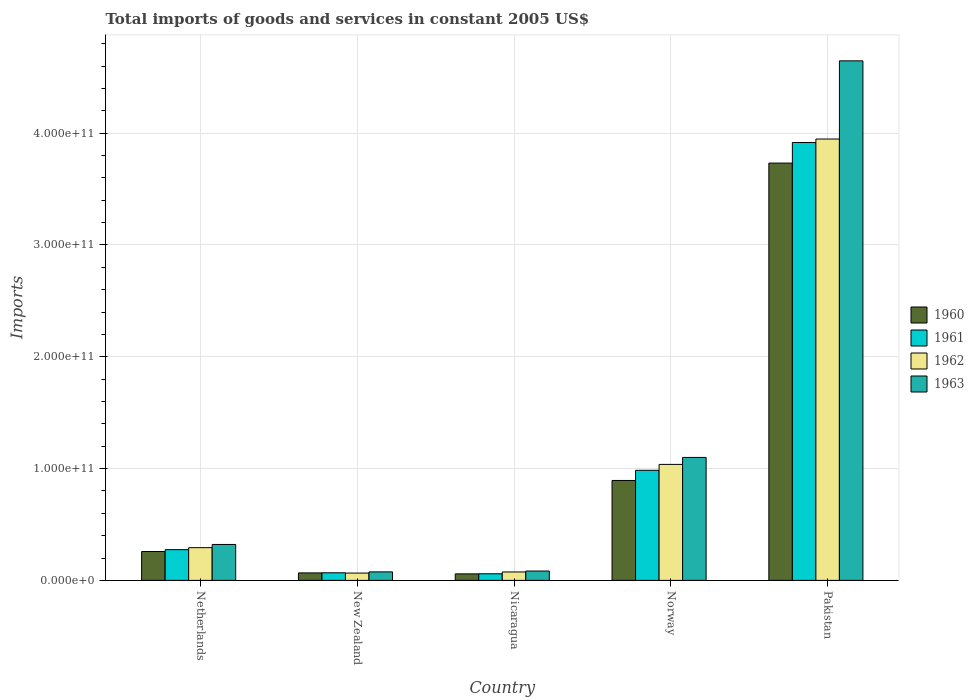How many different coloured bars are there?
Your answer should be compact. 4. How many bars are there on the 2nd tick from the right?
Your answer should be very brief. 4. What is the total imports of goods and services in 1963 in New Zealand?
Your answer should be compact. 7.62e+09. Across all countries, what is the maximum total imports of goods and services in 1962?
Provide a short and direct response. 3.95e+11. Across all countries, what is the minimum total imports of goods and services in 1962?
Make the answer very short. 6.55e+09. In which country was the total imports of goods and services in 1963 minimum?
Keep it short and to the point. New Zealand. What is the total total imports of goods and services in 1960 in the graph?
Give a very brief answer. 5.01e+11. What is the difference between the total imports of goods and services in 1960 in Norway and that in Pakistan?
Provide a succinct answer. -2.84e+11. What is the difference between the total imports of goods and services in 1960 in Netherlands and the total imports of goods and services in 1962 in Norway?
Make the answer very short. -7.79e+1. What is the average total imports of goods and services in 1960 per country?
Your answer should be compact. 1.00e+11. What is the difference between the total imports of goods and services of/in 1960 and total imports of goods and services of/in 1962 in Pakistan?
Offer a very short reply. -2.15e+1. In how many countries, is the total imports of goods and services in 1960 greater than 420000000000 US$?
Offer a terse response. 0. What is the ratio of the total imports of goods and services in 1962 in Nicaragua to that in Pakistan?
Ensure brevity in your answer.  0.02. What is the difference between the highest and the second highest total imports of goods and services in 1960?
Provide a succinct answer. 2.84e+11. What is the difference between the highest and the lowest total imports of goods and services in 1962?
Your answer should be compact. 3.88e+11. Is the sum of the total imports of goods and services in 1960 in Netherlands and New Zealand greater than the maximum total imports of goods and services in 1961 across all countries?
Make the answer very short. No. What does the 3rd bar from the right in Pakistan represents?
Offer a very short reply. 1961. What is the difference between two consecutive major ticks on the Y-axis?
Keep it short and to the point. 1.00e+11. Are the values on the major ticks of Y-axis written in scientific E-notation?
Your response must be concise. Yes. Does the graph contain any zero values?
Give a very brief answer. No. Does the graph contain grids?
Your answer should be very brief. Yes. Where does the legend appear in the graph?
Your response must be concise. Center right. How are the legend labels stacked?
Offer a terse response. Vertical. What is the title of the graph?
Offer a very short reply. Total imports of goods and services in constant 2005 US$. Does "2011" appear as one of the legend labels in the graph?
Keep it short and to the point. No. What is the label or title of the X-axis?
Provide a short and direct response. Country. What is the label or title of the Y-axis?
Ensure brevity in your answer.  Imports. What is the Imports of 1960 in Netherlands?
Give a very brief answer. 2.58e+1. What is the Imports in 1961 in Netherlands?
Your answer should be very brief. 2.75e+1. What is the Imports of 1962 in Netherlands?
Your response must be concise. 2.93e+1. What is the Imports in 1963 in Netherlands?
Provide a short and direct response. 3.21e+1. What is the Imports of 1960 in New Zealand?
Offer a very short reply. 6.71e+09. What is the Imports in 1961 in New Zealand?
Make the answer very short. 6.81e+09. What is the Imports in 1962 in New Zealand?
Offer a terse response. 6.55e+09. What is the Imports of 1963 in New Zealand?
Keep it short and to the point. 7.62e+09. What is the Imports of 1960 in Nicaragua?
Your answer should be very brief. 5.84e+09. What is the Imports in 1961 in Nicaragua?
Ensure brevity in your answer.  5.92e+09. What is the Imports of 1962 in Nicaragua?
Offer a terse response. 7.54e+09. What is the Imports in 1963 in Nicaragua?
Give a very brief answer. 8.36e+09. What is the Imports of 1960 in Norway?
Provide a succinct answer. 8.94e+1. What is the Imports of 1961 in Norway?
Provide a short and direct response. 9.85e+1. What is the Imports in 1962 in Norway?
Offer a terse response. 1.04e+11. What is the Imports of 1963 in Norway?
Provide a succinct answer. 1.10e+11. What is the Imports in 1960 in Pakistan?
Ensure brevity in your answer.  3.73e+11. What is the Imports of 1961 in Pakistan?
Your response must be concise. 3.92e+11. What is the Imports in 1962 in Pakistan?
Make the answer very short. 3.95e+11. What is the Imports in 1963 in Pakistan?
Your answer should be compact. 4.65e+11. Across all countries, what is the maximum Imports in 1960?
Ensure brevity in your answer.  3.73e+11. Across all countries, what is the maximum Imports in 1961?
Keep it short and to the point. 3.92e+11. Across all countries, what is the maximum Imports of 1962?
Your answer should be very brief. 3.95e+11. Across all countries, what is the maximum Imports in 1963?
Your response must be concise. 4.65e+11. Across all countries, what is the minimum Imports of 1960?
Keep it short and to the point. 5.84e+09. Across all countries, what is the minimum Imports of 1961?
Make the answer very short. 5.92e+09. Across all countries, what is the minimum Imports in 1962?
Offer a terse response. 6.55e+09. Across all countries, what is the minimum Imports of 1963?
Provide a succinct answer. 7.62e+09. What is the total Imports of 1960 in the graph?
Make the answer very short. 5.01e+11. What is the total Imports in 1961 in the graph?
Keep it short and to the point. 5.30e+11. What is the total Imports of 1962 in the graph?
Your answer should be compact. 5.42e+11. What is the total Imports in 1963 in the graph?
Provide a succinct answer. 6.23e+11. What is the difference between the Imports of 1960 in Netherlands and that in New Zealand?
Your answer should be compact. 1.91e+1. What is the difference between the Imports of 1961 in Netherlands and that in New Zealand?
Offer a very short reply. 2.07e+1. What is the difference between the Imports in 1962 in Netherlands and that in New Zealand?
Your answer should be compact. 2.27e+1. What is the difference between the Imports of 1963 in Netherlands and that in New Zealand?
Provide a short and direct response. 2.45e+1. What is the difference between the Imports in 1960 in Netherlands and that in Nicaragua?
Keep it short and to the point. 2.00e+1. What is the difference between the Imports of 1961 in Netherlands and that in Nicaragua?
Provide a succinct answer. 2.16e+1. What is the difference between the Imports of 1962 in Netherlands and that in Nicaragua?
Your answer should be very brief. 2.17e+1. What is the difference between the Imports in 1963 in Netherlands and that in Nicaragua?
Offer a very short reply. 2.38e+1. What is the difference between the Imports of 1960 in Netherlands and that in Norway?
Your response must be concise. -6.35e+1. What is the difference between the Imports in 1961 in Netherlands and that in Norway?
Give a very brief answer. -7.10e+1. What is the difference between the Imports in 1962 in Netherlands and that in Norway?
Provide a succinct answer. -7.45e+1. What is the difference between the Imports of 1963 in Netherlands and that in Norway?
Provide a succinct answer. -7.78e+1. What is the difference between the Imports of 1960 in Netherlands and that in Pakistan?
Offer a very short reply. -3.47e+11. What is the difference between the Imports of 1961 in Netherlands and that in Pakistan?
Your answer should be very brief. -3.64e+11. What is the difference between the Imports in 1962 in Netherlands and that in Pakistan?
Your response must be concise. -3.66e+11. What is the difference between the Imports of 1963 in Netherlands and that in Pakistan?
Provide a short and direct response. -4.33e+11. What is the difference between the Imports of 1960 in New Zealand and that in Nicaragua?
Offer a terse response. 8.66e+08. What is the difference between the Imports in 1961 in New Zealand and that in Nicaragua?
Provide a short and direct response. 8.81e+08. What is the difference between the Imports of 1962 in New Zealand and that in Nicaragua?
Offer a terse response. -9.91e+08. What is the difference between the Imports of 1963 in New Zealand and that in Nicaragua?
Make the answer very short. -7.46e+08. What is the difference between the Imports of 1960 in New Zealand and that in Norway?
Ensure brevity in your answer.  -8.27e+1. What is the difference between the Imports of 1961 in New Zealand and that in Norway?
Make the answer very short. -9.17e+1. What is the difference between the Imports in 1962 in New Zealand and that in Norway?
Give a very brief answer. -9.72e+1. What is the difference between the Imports of 1963 in New Zealand and that in Norway?
Make the answer very short. -1.02e+11. What is the difference between the Imports of 1960 in New Zealand and that in Pakistan?
Your answer should be very brief. -3.67e+11. What is the difference between the Imports of 1961 in New Zealand and that in Pakistan?
Provide a short and direct response. -3.85e+11. What is the difference between the Imports in 1962 in New Zealand and that in Pakistan?
Keep it short and to the point. -3.88e+11. What is the difference between the Imports of 1963 in New Zealand and that in Pakistan?
Make the answer very short. -4.57e+11. What is the difference between the Imports in 1960 in Nicaragua and that in Norway?
Ensure brevity in your answer.  -8.35e+1. What is the difference between the Imports in 1961 in Nicaragua and that in Norway?
Offer a terse response. -9.25e+1. What is the difference between the Imports in 1962 in Nicaragua and that in Norway?
Your answer should be compact. -9.62e+1. What is the difference between the Imports in 1963 in Nicaragua and that in Norway?
Ensure brevity in your answer.  -1.02e+11. What is the difference between the Imports in 1960 in Nicaragua and that in Pakistan?
Give a very brief answer. -3.67e+11. What is the difference between the Imports of 1961 in Nicaragua and that in Pakistan?
Keep it short and to the point. -3.86e+11. What is the difference between the Imports in 1962 in Nicaragua and that in Pakistan?
Make the answer very short. -3.87e+11. What is the difference between the Imports in 1963 in Nicaragua and that in Pakistan?
Offer a very short reply. -4.56e+11. What is the difference between the Imports in 1960 in Norway and that in Pakistan?
Provide a succinct answer. -2.84e+11. What is the difference between the Imports of 1961 in Norway and that in Pakistan?
Offer a terse response. -2.93e+11. What is the difference between the Imports of 1962 in Norway and that in Pakistan?
Ensure brevity in your answer.  -2.91e+11. What is the difference between the Imports of 1963 in Norway and that in Pakistan?
Your answer should be compact. -3.55e+11. What is the difference between the Imports of 1960 in Netherlands and the Imports of 1961 in New Zealand?
Offer a very short reply. 1.90e+1. What is the difference between the Imports in 1960 in Netherlands and the Imports in 1962 in New Zealand?
Offer a terse response. 1.93e+1. What is the difference between the Imports in 1960 in Netherlands and the Imports in 1963 in New Zealand?
Give a very brief answer. 1.82e+1. What is the difference between the Imports in 1961 in Netherlands and the Imports in 1962 in New Zealand?
Ensure brevity in your answer.  2.10e+1. What is the difference between the Imports of 1961 in Netherlands and the Imports of 1963 in New Zealand?
Give a very brief answer. 1.99e+1. What is the difference between the Imports in 1962 in Netherlands and the Imports in 1963 in New Zealand?
Offer a terse response. 2.17e+1. What is the difference between the Imports of 1960 in Netherlands and the Imports of 1961 in Nicaragua?
Keep it short and to the point. 1.99e+1. What is the difference between the Imports of 1960 in Netherlands and the Imports of 1962 in Nicaragua?
Your answer should be very brief. 1.83e+1. What is the difference between the Imports in 1960 in Netherlands and the Imports in 1963 in Nicaragua?
Your response must be concise. 1.75e+1. What is the difference between the Imports of 1961 in Netherlands and the Imports of 1962 in Nicaragua?
Keep it short and to the point. 2.00e+1. What is the difference between the Imports in 1961 in Netherlands and the Imports in 1963 in Nicaragua?
Your answer should be compact. 1.91e+1. What is the difference between the Imports in 1962 in Netherlands and the Imports in 1963 in Nicaragua?
Offer a terse response. 2.09e+1. What is the difference between the Imports of 1960 in Netherlands and the Imports of 1961 in Norway?
Provide a short and direct response. -7.26e+1. What is the difference between the Imports of 1960 in Netherlands and the Imports of 1962 in Norway?
Your response must be concise. -7.79e+1. What is the difference between the Imports in 1960 in Netherlands and the Imports in 1963 in Norway?
Offer a terse response. -8.41e+1. What is the difference between the Imports in 1961 in Netherlands and the Imports in 1962 in Norway?
Make the answer very short. -7.62e+1. What is the difference between the Imports of 1961 in Netherlands and the Imports of 1963 in Norway?
Provide a succinct answer. -8.25e+1. What is the difference between the Imports of 1962 in Netherlands and the Imports of 1963 in Norway?
Provide a succinct answer. -8.07e+1. What is the difference between the Imports in 1960 in Netherlands and the Imports in 1961 in Pakistan?
Offer a very short reply. -3.66e+11. What is the difference between the Imports in 1960 in Netherlands and the Imports in 1962 in Pakistan?
Ensure brevity in your answer.  -3.69e+11. What is the difference between the Imports in 1960 in Netherlands and the Imports in 1963 in Pakistan?
Provide a short and direct response. -4.39e+11. What is the difference between the Imports of 1961 in Netherlands and the Imports of 1962 in Pakistan?
Your answer should be compact. -3.67e+11. What is the difference between the Imports of 1961 in Netherlands and the Imports of 1963 in Pakistan?
Provide a succinct answer. -4.37e+11. What is the difference between the Imports in 1962 in Netherlands and the Imports in 1963 in Pakistan?
Your answer should be compact. -4.35e+11. What is the difference between the Imports in 1960 in New Zealand and the Imports in 1961 in Nicaragua?
Ensure brevity in your answer.  7.83e+08. What is the difference between the Imports in 1960 in New Zealand and the Imports in 1962 in Nicaragua?
Provide a short and direct response. -8.30e+08. What is the difference between the Imports of 1960 in New Zealand and the Imports of 1963 in Nicaragua?
Ensure brevity in your answer.  -1.66e+09. What is the difference between the Imports in 1961 in New Zealand and the Imports in 1962 in Nicaragua?
Your answer should be very brief. -7.32e+08. What is the difference between the Imports of 1961 in New Zealand and the Imports of 1963 in Nicaragua?
Provide a short and direct response. -1.56e+09. What is the difference between the Imports in 1962 in New Zealand and the Imports in 1963 in Nicaragua?
Your response must be concise. -1.82e+09. What is the difference between the Imports in 1960 in New Zealand and the Imports in 1961 in Norway?
Provide a succinct answer. -9.18e+1. What is the difference between the Imports of 1960 in New Zealand and the Imports of 1962 in Norway?
Your answer should be very brief. -9.70e+1. What is the difference between the Imports of 1960 in New Zealand and the Imports of 1963 in Norway?
Your response must be concise. -1.03e+11. What is the difference between the Imports of 1961 in New Zealand and the Imports of 1962 in Norway?
Your answer should be compact. -9.69e+1. What is the difference between the Imports of 1961 in New Zealand and the Imports of 1963 in Norway?
Provide a succinct answer. -1.03e+11. What is the difference between the Imports of 1962 in New Zealand and the Imports of 1963 in Norway?
Offer a terse response. -1.03e+11. What is the difference between the Imports of 1960 in New Zealand and the Imports of 1961 in Pakistan?
Provide a succinct answer. -3.85e+11. What is the difference between the Imports in 1960 in New Zealand and the Imports in 1962 in Pakistan?
Offer a terse response. -3.88e+11. What is the difference between the Imports in 1960 in New Zealand and the Imports in 1963 in Pakistan?
Provide a short and direct response. -4.58e+11. What is the difference between the Imports in 1961 in New Zealand and the Imports in 1962 in Pakistan?
Make the answer very short. -3.88e+11. What is the difference between the Imports in 1961 in New Zealand and the Imports in 1963 in Pakistan?
Offer a very short reply. -4.58e+11. What is the difference between the Imports of 1962 in New Zealand and the Imports of 1963 in Pakistan?
Provide a succinct answer. -4.58e+11. What is the difference between the Imports in 1960 in Nicaragua and the Imports in 1961 in Norway?
Your answer should be compact. -9.26e+1. What is the difference between the Imports in 1960 in Nicaragua and the Imports in 1962 in Norway?
Your response must be concise. -9.79e+1. What is the difference between the Imports of 1960 in Nicaragua and the Imports of 1963 in Norway?
Give a very brief answer. -1.04e+11. What is the difference between the Imports in 1961 in Nicaragua and the Imports in 1962 in Norway?
Your answer should be very brief. -9.78e+1. What is the difference between the Imports in 1961 in Nicaragua and the Imports in 1963 in Norway?
Provide a short and direct response. -1.04e+11. What is the difference between the Imports in 1962 in Nicaragua and the Imports in 1963 in Norway?
Offer a terse response. -1.02e+11. What is the difference between the Imports in 1960 in Nicaragua and the Imports in 1961 in Pakistan?
Provide a short and direct response. -3.86e+11. What is the difference between the Imports of 1960 in Nicaragua and the Imports of 1962 in Pakistan?
Ensure brevity in your answer.  -3.89e+11. What is the difference between the Imports of 1960 in Nicaragua and the Imports of 1963 in Pakistan?
Your answer should be compact. -4.59e+11. What is the difference between the Imports of 1961 in Nicaragua and the Imports of 1962 in Pakistan?
Offer a terse response. -3.89e+11. What is the difference between the Imports of 1961 in Nicaragua and the Imports of 1963 in Pakistan?
Provide a short and direct response. -4.59e+11. What is the difference between the Imports of 1962 in Nicaragua and the Imports of 1963 in Pakistan?
Offer a very short reply. -4.57e+11. What is the difference between the Imports of 1960 in Norway and the Imports of 1961 in Pakistan?
Offer a very short reply. -3.02e+11. What is the difference between the Imports in 1960 in Norway and the Imports in 1962 in Pakistan?
Provide a succinct answer. -3.05e+11. What is the difference between the Imports in 1960 in Norway and the Imports in 1963 in Pakistan?
Your answer should be very brief. -3.75e+11. What is the difference between the Imports in 1961 in Norway and the Imports in 1962 in Pakistan?
Make the answer very short. -2.96e+11. What is the difference between the Imports of 1961 in Norway and the Imports of 1963 in Pakistan?
Offer a very short reply. -3.66e+11. What is the difference between the Imports in 1962 in Norway and the Imports in 1963 in Pakistan?
Provide a short and direct response. -3.61e+11. What is the average Imports of 1960 per country?
Provide a succinct answer. 1.00e+11. What is the average Imports of 1961 per country?
Ensure brevity in your answer.  1.06e+11. What is the average Imports in 1962 per country?
Your answer should be compact. 1.08e+11. What is the average Imports of 1963 per country?
Your response must be concise. 1.25e+11. What is the difference between the Imports of 1960 and Imports of 1961 in Netherlands?
Keep it short and to the point. -1.65e+09. What is the difference between the Imports in 1960 and Imports in 1962 in Netherlands?
Offer a very short reply. -3.43e+09. What is the difference between the Imports of 1960 and Imports of 1963 in Netherlands?
Ensure brevity in your answer.  -6.30e+09. What is the difference between the Imports in 1961 and Imports in 1962 in Netherlands?
Your answer should be compact. -1.77e+09. What is the difference between the Imports in 1961 and Imports in 1963 in Netherlands?
Ensure brevity in your answer.  -4.65e+09. What is the difference between the Imports of 1962 and Imports of 1963 in Netherlands?
Make the answer very short. -2.87e+09. What is the difference between the Imports of 1960 and Imports of 1961 in New Zealand?
Make the answer very short. -9.87e+07. What is the difference between the Imports of 1960 and Imports of 1962 in New Zealand?
Ensure brevity in your answer.  1.61e+08. What is the difference between the Imports in 1960 and Imports in 1963 in New Zealand?
Ensure brevity in your answer.  -9.09e+08. What is the difference between the Imports in 1961 and Imports in 1962 in New Zealand?
Keep it short and to the point. 2.60e+08. What is the difference between the Imports in 1961 and Imports in 1963 in New Zealand?
Your answer should be very brief. -8.10e+08. What is the difference between the Imports in 1962 and Imports in 1963 in New Zealand?
Provide a short and direct response. -1.07e+09. What is the difference between the Imports in 1960 and Imports in 1961 in Nicaragua?
Ensure brevity in your answer.  -8.34e+07. What is the difference between the Imports in 1960 and Imports in 1962 in Nicaragua?
Provide a short and direct response. -1.70e+09. What is the difference between the Imports in 1960 and Imports in 1963 in Nicaragua?
Offer a terse response. -2.52e+09. What is the difference between the Imports in 1961 and Imports in 1962 in Nicaragua?
Give a very brief answer. -1.61e+09. What is the difference between the Imports in 1961 and Imports in 1963 in Nicaragua?
Provide a succinct answer. -2.44e+09. What is the difference between the Imports of 1962 and Imports of 1963 in Nicaragua?
Your answer should be very brief. -8.25e+08. What is the difference between the Imports in 1960 and Imports in 1961 in Norway?
Offer a terse response. -9.07e+09. What is the difference between the Imports in 1960 and Imports in 1962 in Norway?
Keep it short and to the point. -1.44e+1. What is the difference between the Imports of 1960 and Imports of 1963 in Norway?
Keep it short and to the point. -2.06e+1. What is the difference between the Imports of 1961 and Imports of 1962 in Norway?
Keep it short and to the point. -5.28e+09. What is the difference between the Imports in 1961 and Imports in 1963 in Norway?
Make the answer very short. -1.15e+1. What is the difference between the Imports of 1962 and Imports of 1963 in Norway?
Offer a very short reply. -6.24e+09. What is the difference between the Imports of 1960 and Imports of 1961 in Pakistan?
Provide a short and direct response. -1.84e+1. What is the difference between the Imports in 1960 and Imports in 1962 in Pakistan?
Keep it short and to the point. -2.15e+1. What is the difference between the Imports of 1960 and Imports of 1963 in Pakistan?
Ensure brevity in your answer.  -9.14e+1. What is the difference between the Imports in 1961 and Imports in 1962 in Pakistan?
Keep it short and to the point. -3.12e+09. What is the difference between the Imports in 1961 and Imports in 1963 in Pakistan?
Ensure brevity in your answer.  -7.30e+1. What is the difference between the Imports in 1962 and Imports in 1963 in Pakistan?
Your answer should be very brief. -6.99e+1. What is the ratio of the Imports in 1960 in Netherlands to that in New Zealand?
Keep it short and to the point. 3.85. What is the ratio of the Imports in 1961 in Netherlands to that in New Zealand?
Ensure brevity in your answer.  4.04. What is the ratio of the Imports in 1962 in Netherlands to that in New Zealand?
Offer a terse response. 4.47. What is the ratio of the Imports in 1963 in Netherlands to that in New Zealand?
Make the answer very short. 4.22. What is the ratio of the Imports of 1960 in Netherlands to that in Nicaragua?
Ensure brevity in your answer.  4.42. What is the ratio of the Imports of 1961 in Netherlands to that in Nicaragua?
Offer a terse response. 4.64. What is the ratio of the Imports of 1962 in Netherlands to that in Nicaragua?
Offer a terse response. 3.88. What is the ratio of the Imports of 1963 in Netherlands to that in Nicaragua?
Give a very brief answer. 3.84. What is the ratio of the Imports in 1960 in Netherlands to that in Norway?
Your response must be concise. 0.29. What is the ratio of the Imports in 1961 in Netherlands to that in Norway?
Provide a short and direct response. 0.28. What is the ratio of the Imports in 1962 in Netherlands to that in Norway?
Make the answer very short. 0.28. What is the ratio of the Imports of 1963 in Netherlands to that in Norway?
Provide a short and direct response. 0.29. What is the ratio of the Imports in 1960 in Netherlands to that in Pakistan?
Provide a short and direct response. 0.07. What is the ratio of the Imports in 1961 in Netherlands to that in Pakistan?
Your answer should be compact. 0.07. What is the ratio of the Imports of 1962 in Netherlands to that in Pakistan?
Ensure brevity in your answer.  0.07. What is the ratio of the Imports of 1963 in Netherlands to that in Pakistan?
Give a very brief answer. 0.07. What is the ratio of the Imports in 1960 in New Zealand to that in Nicaragua?
Your answer should be compact. 1.15. What is the ratio of the Imports in 1961 in New Zealand to that in Nicaragua?
Provide a short and direct response. 1.15. What is the ratio of the Imports of 1962 in New Zealand to that in Nicaragua?
Your response must be concise. 0.87. What is the ratio of the Imports in 1963 in New Zealand to that in Nicaragua?
Your answer should be very brief. 0.91. What is the ratio of the Imports in 1960 in New Zealand to that in Norway?
Give a very brief answer. 0.07. What is the ratio of the Imports in 1961 in New Zealand to that in Norway?
Make the answer very short. 0.07. What is the ratio of the Imports of 1962 in New Zealand to that in Norway?
Keep it short and to the point. 0.06. What is the ratio of the Imports of 1963 in New Zealand to that in Norway?
Give a very brief answer. 0.07. What is the ratio of the Imports of 1960 in New Zealand to that in Pakistan?
Ensure brevity in your answer.  0.02. What is the ratio of the Imports in 1961 in New Zealand to that in Pakistan?
Provide a succinct answer. 0.02. What is the ratio of the Imports of 1962 in New Zealand to that in Pakistan?
Offer a very short reply. 0.02. What is the ratio of the Imports of 1963 in New Zealand to that in Pakistan?
Offer a terse response. 0.02. What is the ratio of the Imports in 1960 in Nicaragua to that in Norway?
Your answer should be very brief. 0.07. What is the ratio of the Imports in 1961 in Nicaragua to that in Norway?
Offer a very short reply. 0.06. What is the ratio of the Imports in 1962 in Nicaragua to that in Norway?
Keep it short and to the point. 0.07. What is the ratio of the Imports in 1963 in Nicaragua to that in Norway?
Ensure brevity in your answer.  0.08. What is the ratio of the Imports in 1960 in Nicaragua to that in Pakistan?
Keep it short and to the point. 0.02. What is the ratio of the Imports of 1961 in Nicaragua to that in Pakistan?
Offer a terse response. 0.02. What is the ratio of the Imports in 1962 in Nicaragua to that in Pakistan?
Ensure brevity in your answer.  0.02. What is the ratio of the Imports in 1963 in Nicaragua to that in Pakistan?
Offer a terse response. 0.02. What is the ratio of the Imports of 1960 in Norway to that in Pakistan?
Provide a short and direct response. 0.24. What is the ratio of the Imports of 1961 in Norway to that in Pakistan?
Ensure brevity in your answer.  0.25. What is the ratio of the Imports in 1962 in Norway to that in Pakistan?
Ensure brevity in your answer.  0.26. What is the ratio of the Imports in 1963 in Norway to that in Pakistan?
Ensure brevity in your answer.  0.24. What is the difference between the highest and the second highest Imports in 1960?
Provide a short and direct response. 2.84e+11. What is the difference between the highest and the second highest Imports of 1961?
Your response must be concise. 2.93e+11. What is the difference between the highest and the second highest Imports of 1962?
Your answer should be compact. 2.91e+11. What is the difference between the highest and the second highest Imports of 1963?
Ensure brevity in your answer.  3.55e+11. What is the difference between the highest and the lowest Imports of 1960?
Provide a succinct answer. 3.67e+11. What is the difference between the highest and the lowest Imports of 1961?
Offer a very short reply. 3.86e+11. What is the difference between the highest and the lowest Imports in 1962?
Offer a terse response. 3.88e+11. What is the difference between the highest and the lowest Imports in 1963?
Offer a terse response. 4.57e+11. 